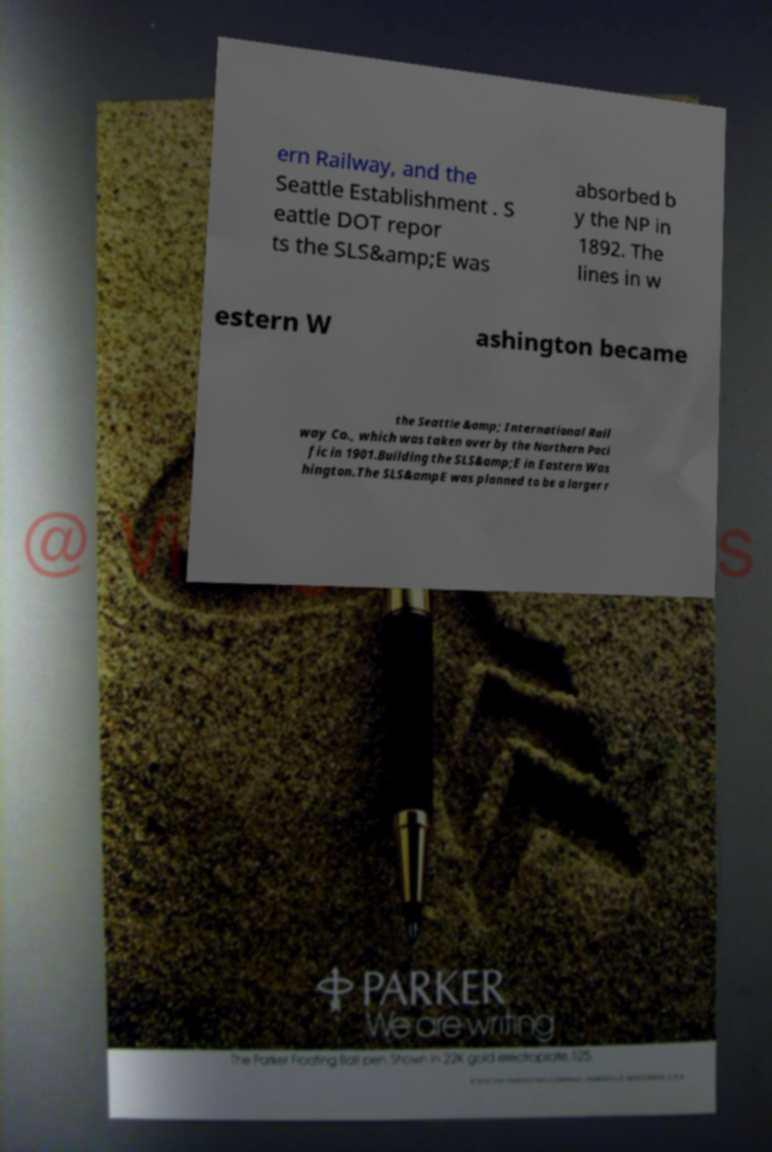For documentation purposes, I need the text within this image transcribed. Could you provide that? ern Railway, and the Seattle Establishment . S eattle DOT repor ts the SLS&amp;E was absorbed b y the NP in 1892. The lines in w estern W ashington became the Seattle &amp; International Rail way Co., which was taken over by the Northern Paci fic in 1901.Building the SLS&amp;E in Eastern Was hington.The SLS&ampE was planned to be a larger r 